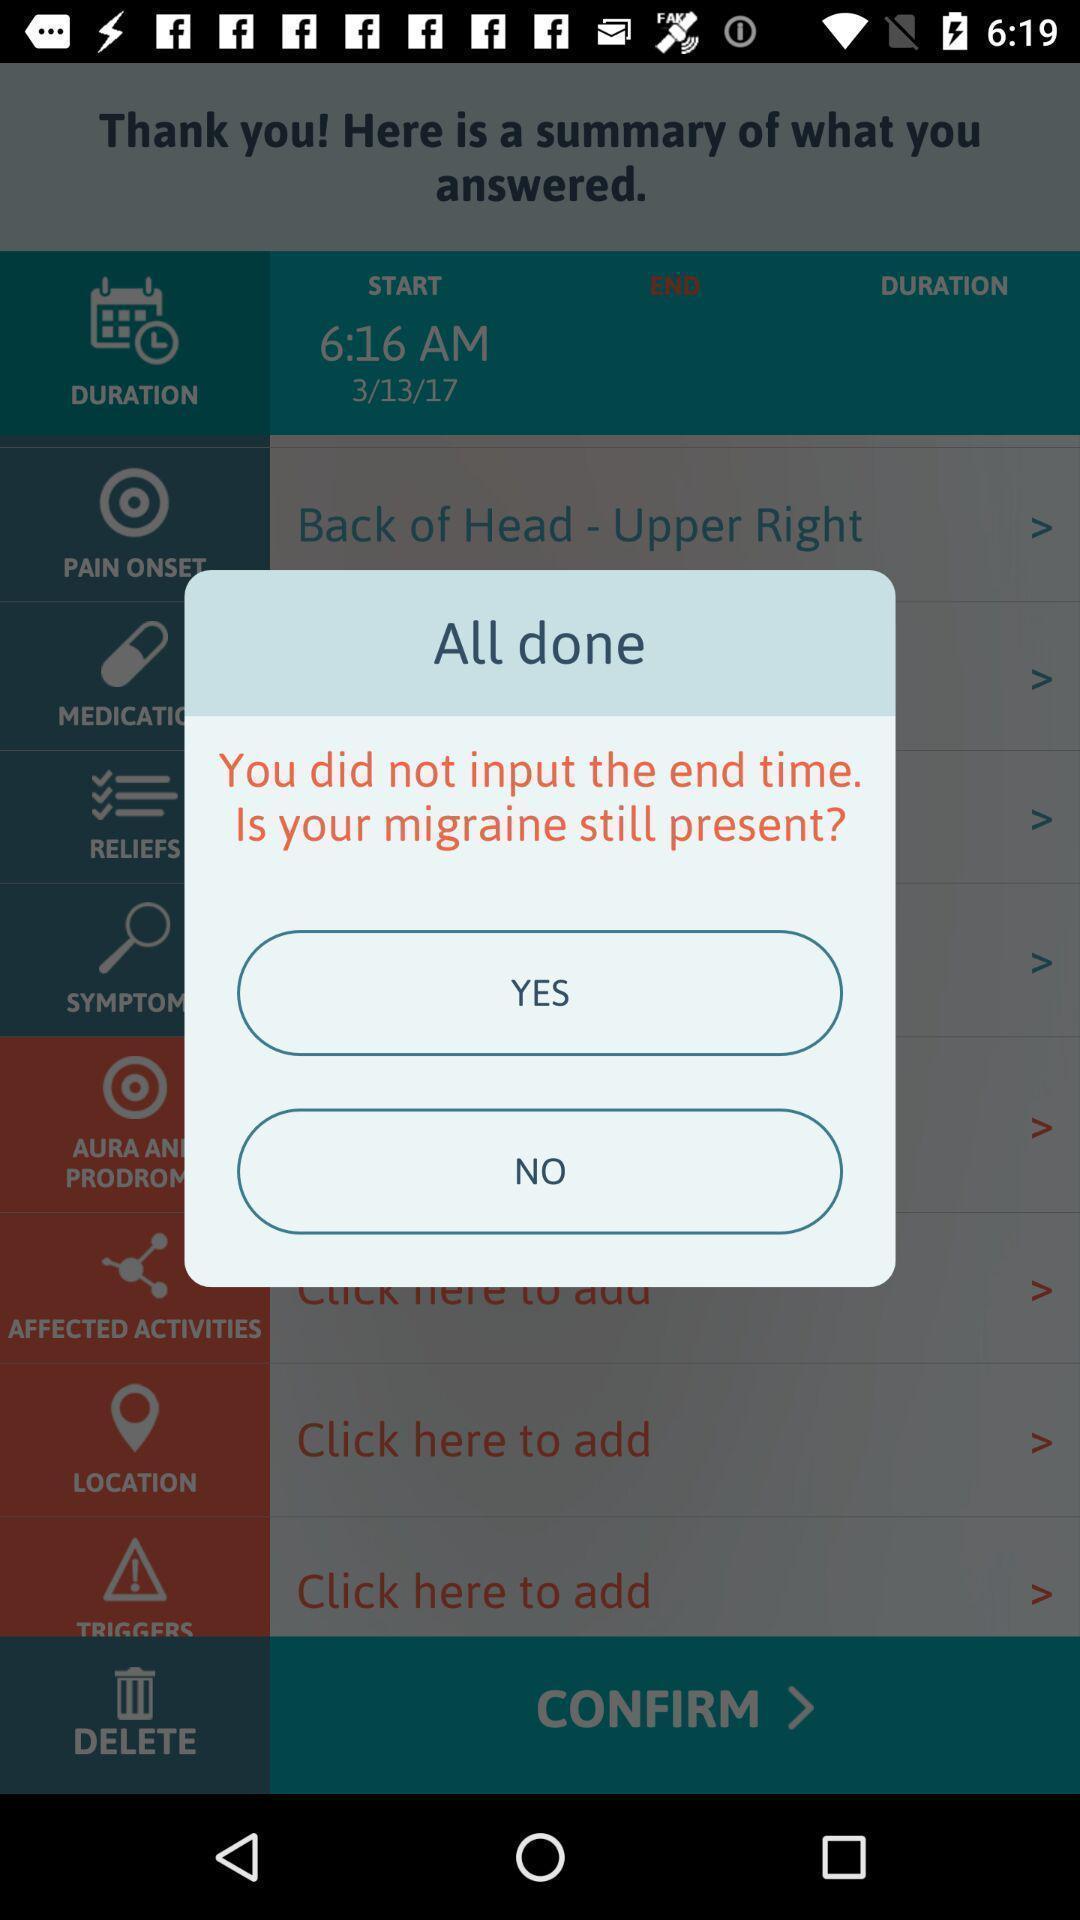What details can you identify in this image? Pop-up showing multiple options for migraine. 